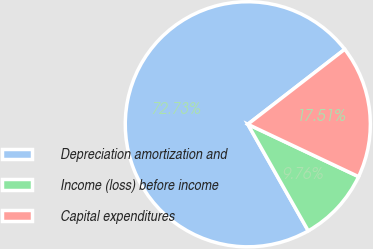Convert chart. <chart><loc_0><loc_0><loc_500><loc_500><pie_chart><fcel>Depreciation amortization and<fcel>Income (loss) before income<fcel>Capital expenditures<nl><fcel>72.73%<fcel>9.76%<fcel>17.51%<nl></chart> 